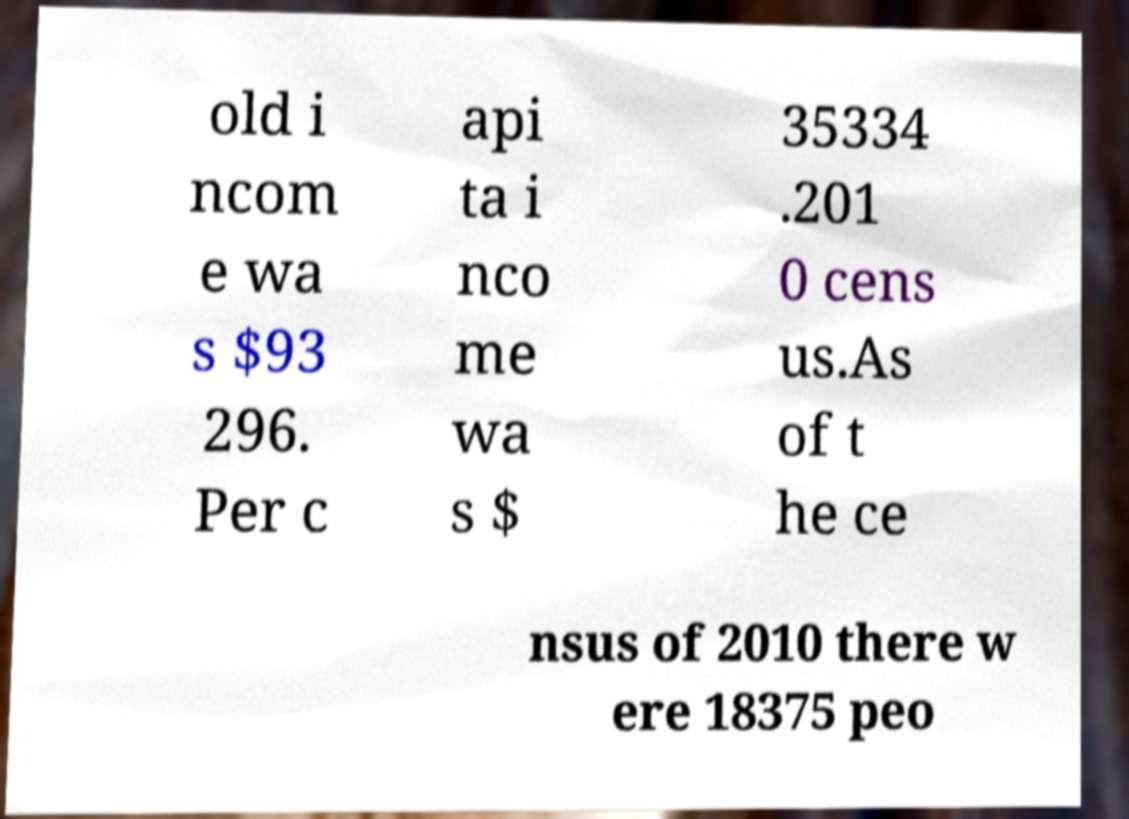For documentation purposes, I need the text within this image transcribed. Could you provide that? old i ncom e wa s $93 296. Per c api ta i nco me wa s $ 35334 .201 0 cens us.As of t he ce nsus of 2010 there w ere 18375 peo 